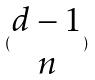<formula> <loc_0><loc_0><loc_500><loc_500>( \begin{matrix} d - 1 \\ n \end{matrix} )</formula> 